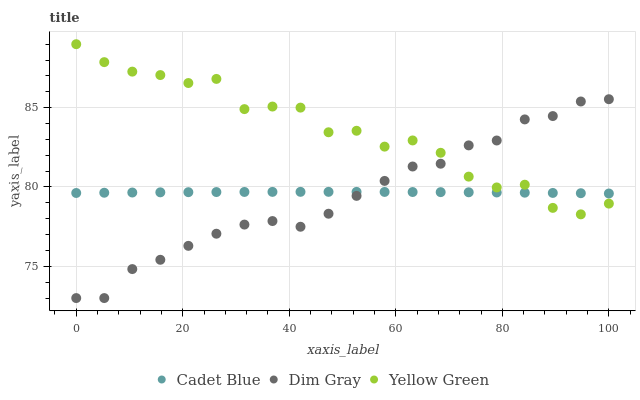Does Dim Gray have the minimum area under the curve?
Answer yes or no. Yes. Does Yellow Green have the maximum area under the curve?
Answer yes or no. Yes. Does Cadet Blue have the minimum area under the curve?
Answer yes or no. No. Does Cadet Blue have the maximum area under the curve?
Answer yes or no. No. Is Cadet Blue the smoothest?
Answer yes or no. Yes. Is Yellow Green the roughest?
Answer yes or no. Yes. Is Yellow Green the smoothest?
Answer yes or no. No. Is Cadet Blue the roughest?
Answer yes or no. No. Does Dim Gray have the lowest value?
Answer yes or no. Yes. Does Yellow Green have the lowest value?
Answer yes or no. No. Does Yellow Green have the highest value?
Answer yes or no. Yes. Does Cadet Blue have the highest value?
Answer yes or no. No. Does Dim Gray intersect Cadet Blue?
Answer yes or no. Yes. Is Dim Gray less than Cadet Blue?
Answer yes or no. No. Is Dim Gray greater than Cadet Blue?
Answer yes or no. No. 